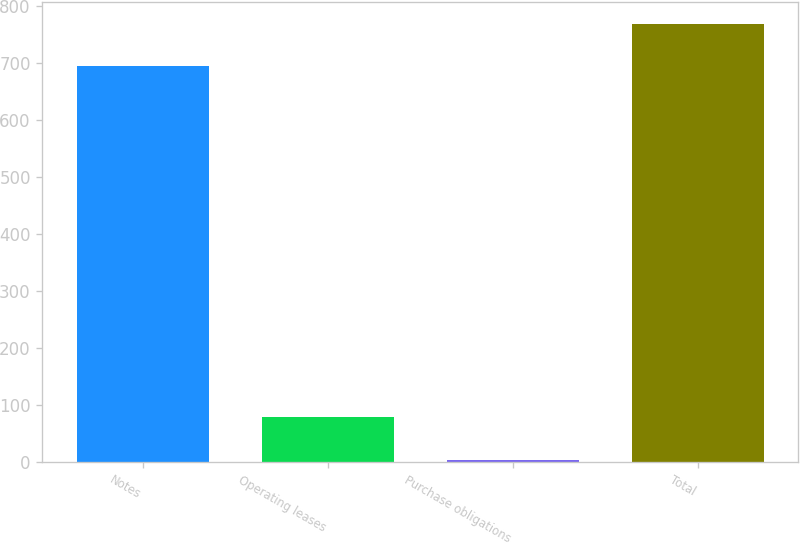<chart> <loc_0><loc_0><loc_500><loc_500><bar_chart><fcel>Notes<fcel>Operating leases<fcel>Purchase obligations<fcel>Total<nl><fcel>695.3<fcel>78.12<fcel>4.2<fcel>769.22<nl></chart> 